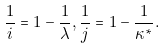Convert formula to latex. <formula><loc_0><loc_0><loc_500><loc_500>\frac { 1 } { i } = 1 - \frac { 1 } { \lambda } , \frac { 1 } { j } = 1 - \frac { 1 } { \kappa ^ { * } } .</formula> 